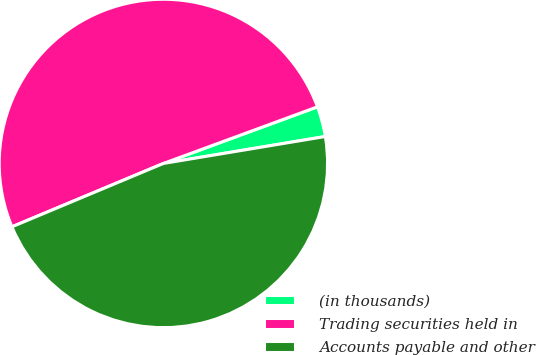<chart> <loc_0><loc_0><loc_500><loc_500><pie_chart><fcel>(in thousands)<fcel>Trading securities held in<fcel>Accounts payable and other<nl><fcel>2.98%<fcel>50.7%<fcel>46.32%<nl></chart> 